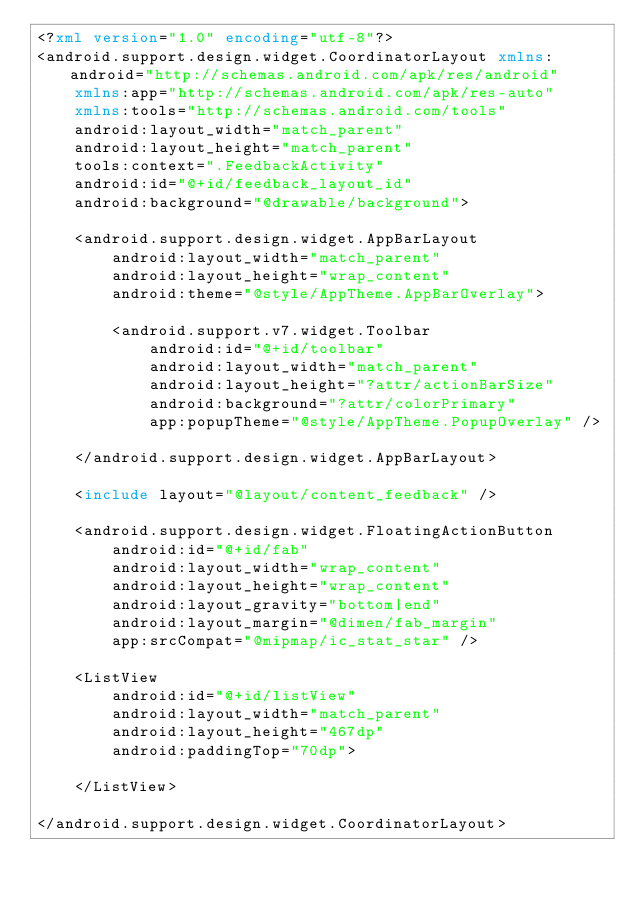<code> <loc_0><loc_0><loc_500><loc_500><_XML_><?xml version="1.0" encoding="utf-8"?>
<android.support.design.widget.CoordinatorLayout xmlns:android="http://schemas.android.com/apk/res/android"
    xmlns:app="http://schemas.android.com/apk/res-auto"
    xmlns:tools="http://schemas.android.com/tools"
    android:layout_width="match_parent"
    android:layout_height="match_parent"
    tools:context=".FeedbackActivity"
    android:id="@+id/feedback_layout_id"
    android:background="@drawable/background">

    <android.support.design.widget.AppBarLayout
        android:layout_width="match_parent"
        android:layout_height="wrap_content"
        android:theme="@style/AppTheme.AppBarOverlay">

        <android.support.v7.widget.Toolbar
            android:id="@+id/toolbar"
            android:layout_width="match_parent"
            android:layout_height="?attr/actionBarSize"
            android:background="?attr/colorPrimary"
            app:popupTheme="@style/AppTheme.PopupOverlay" />

    </android.support.design.widget.AppBarLayout>

    <include layout="@layout/content_feedback" />

    <android.support.design.widget.FloatingActionButton
        android:id="@+id/fab"
        android:layout_width="wrap_content"
        android:layout_height="wrap_content"
        android:layout_gravity="bottom|end"
        android:layout_margin="@dimen/fab_margin"
        app:srcCompat="@mipmap/ic_stat_star" />

    <ListView
        android:id="@+id/listView"
        android:layout_width="match_parent"
        android:layout_height="467dp"
        android:paddingTop="70dp">

    </ListView>

</android.support.design.widget.CoordinatorLayout></code> 